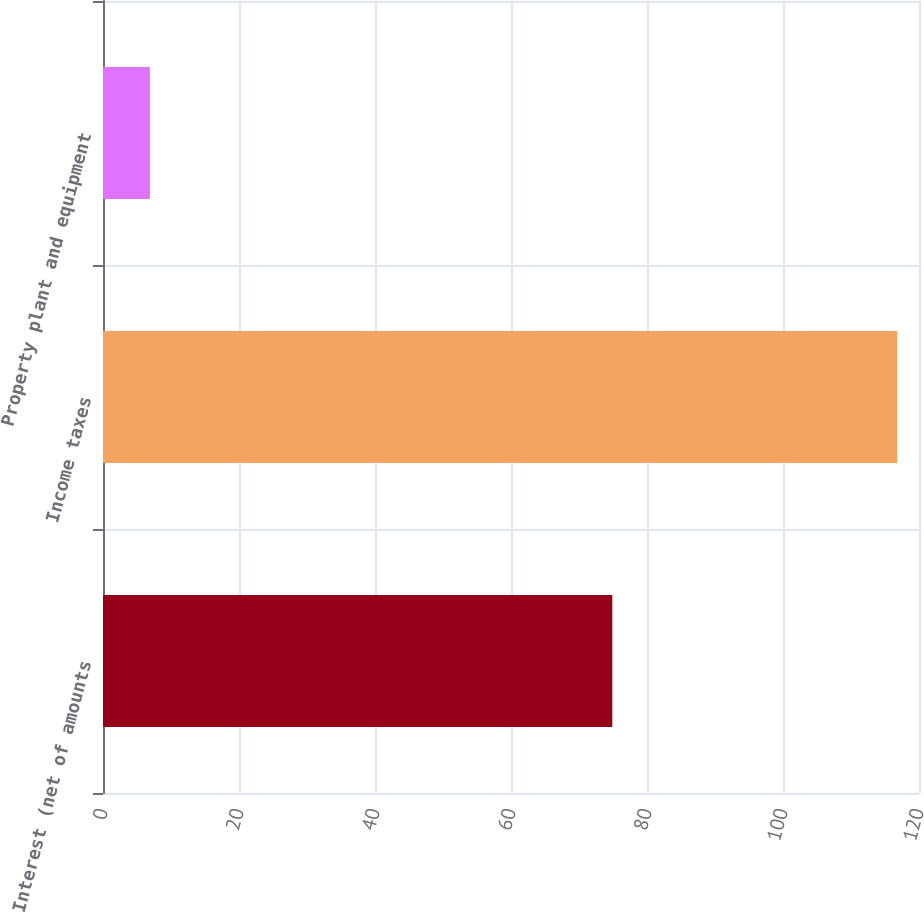<chart> <loc_0><loc_0><loc_500><loc_500><bar_chart><fcel>Interest (net of amounts<fcel>Income taxes<fcel>Property plant and equipment<nl><fcel>74.9<fcel>116.8<fcel>6.9<nl></chart> 